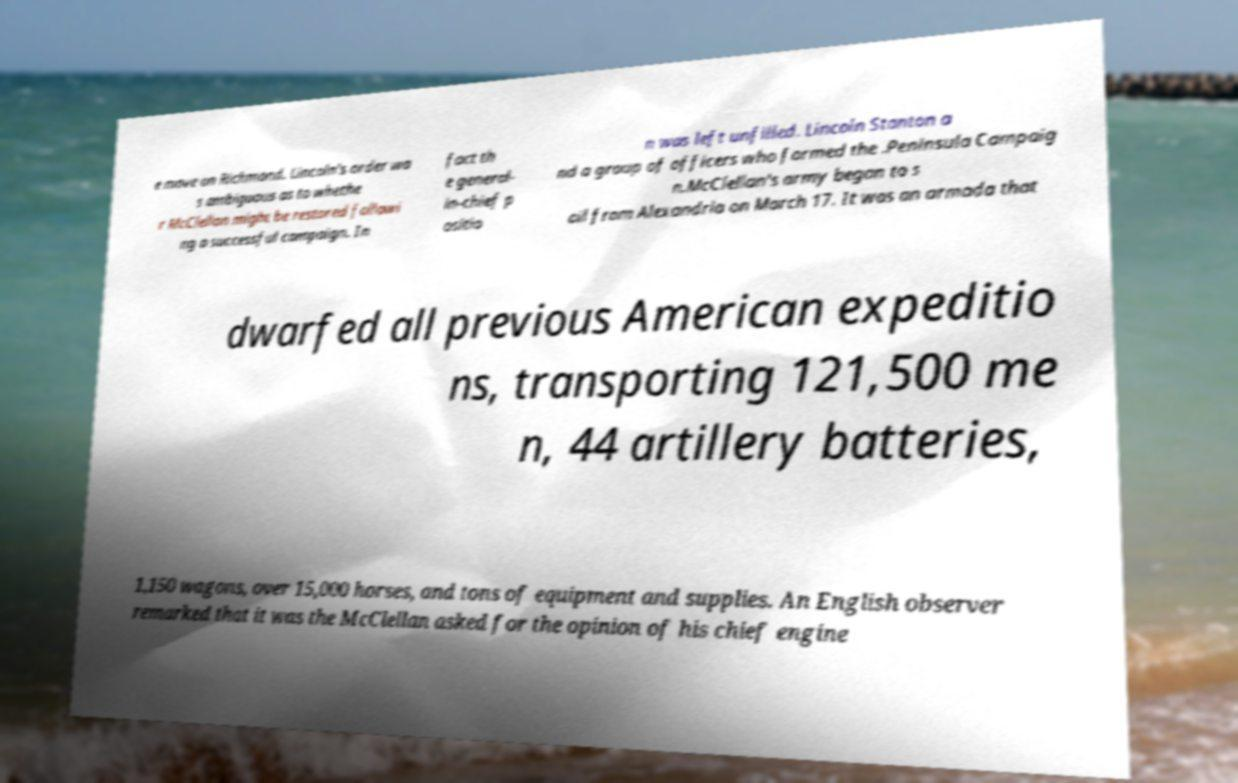Could you extract and type out the text from this image? e move on Richmond. Lincoln's order wa s ambiguous as to whethe r McClellan might be restored followi ng a successful campaign. In fact th e general- in-chief p ositio n was left unfilled. Lincoln Stanton a nd a group of officers who formed the .Peninsula Campaig n.McClellan's army began to s ail from Alexandria on March 17. It was an armada that dwarfed all previous American expeditio ns, transporting 121,500 me n, 44 artillery batteries, 1,150 wagons, over 15,000 horses, and tons of equipment and supplies. An English observer remarked that it was the McClellan asked for the opinion of his chief engine 